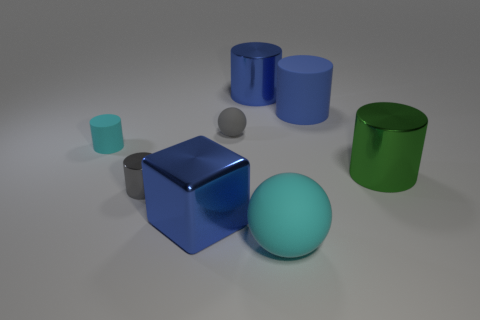Subtract all large rubber cylinders. How many cylinders are left? 4 Add 1 big green metal balls. How many objects exist? 9 Subtract all cyan spheres. How many spheres are left? 1 Subtract all blocks. How many objects are left? 7 Subtract 1 balls. How many balls are left? 1 Subtract all purple balls. How many blue cylinders are left? 2 Subtract all shiny objects. Subtract all gray objects. How many objects are left? 2 Add 6 tiny gray metal cylinders. How many tiny gray metal cylinders are left? 7 Add 4 tiny brown cylinders. How many tiny brown cylinders exist? 4 Subtract 0 green spheres. How many objects are left? 8 